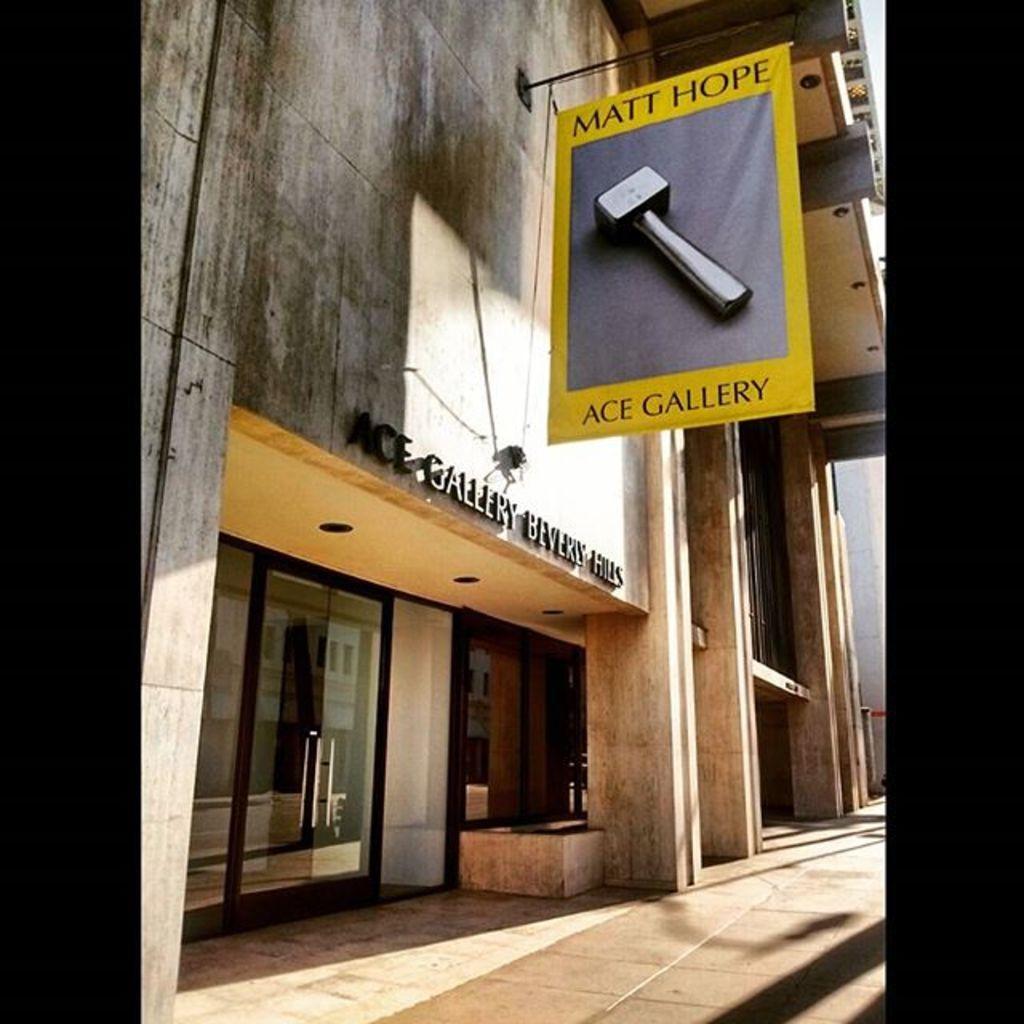How would you summarize this image in a sentence or two? In this image, we can see building, glass doors and banners. There is a name board on the building. On left side, we can see pipe. 